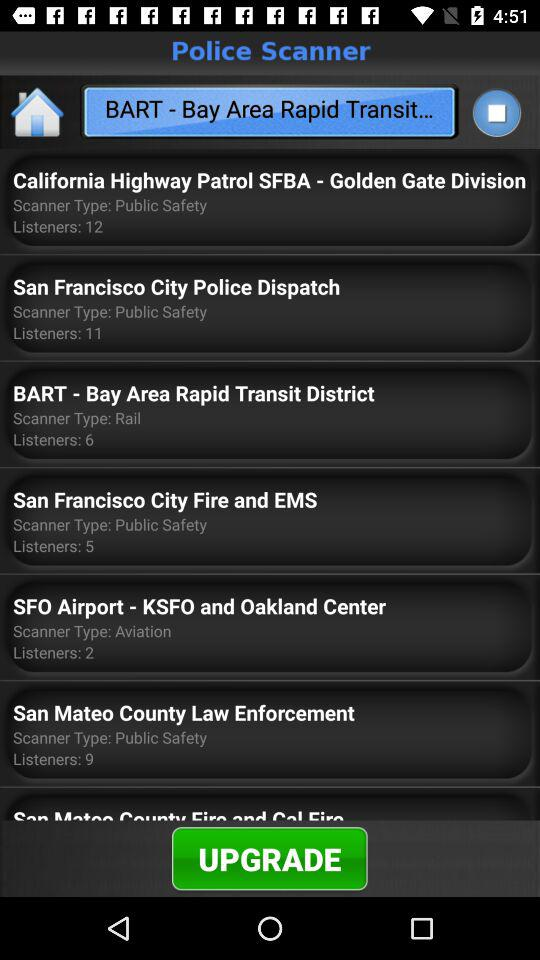What is the scanner type for "San Francisco City Police Dispatch"? The scanner type for "San Francisco City Police Dispatch" is "Public Safety". 